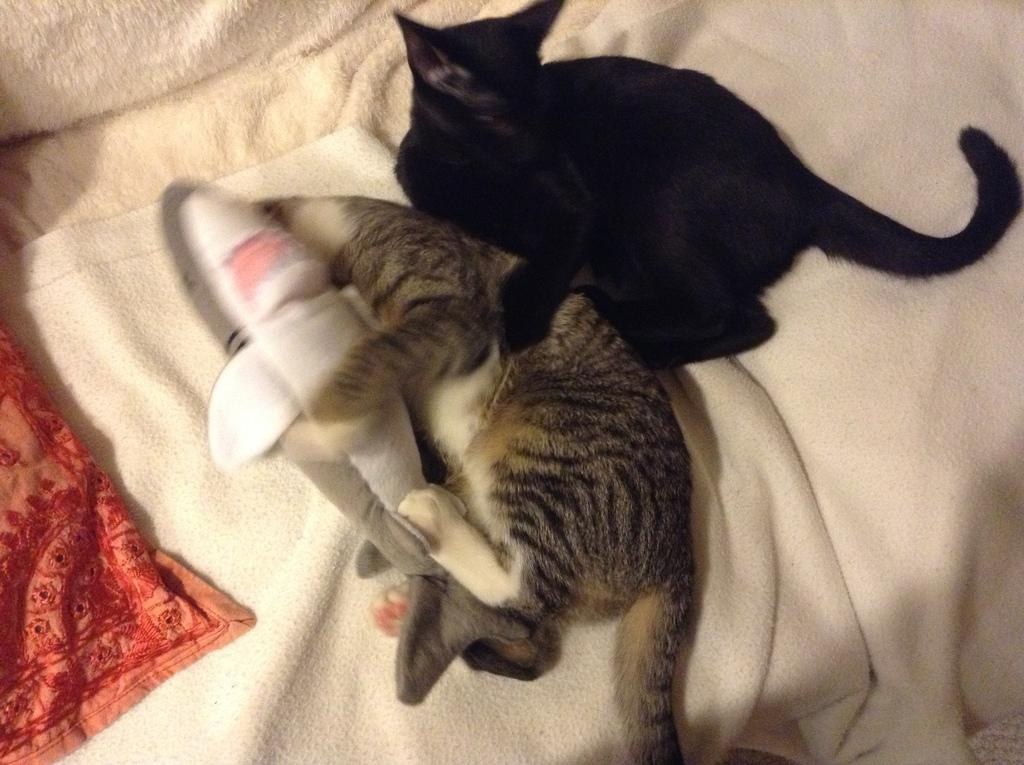What type of animals are in the image? There is a black cat and a grey cat in the image. What are the cats doing in the image? The cats are playing on a bed. What is covering the bed? There is a blanket on the bed. What toy can be seen on the left side of the bed? There is a dolphin toy on the left side of the bed. What historical event is depicted in the image? There is no historical event depicted in the image; it features two cats playing on a bed. What type of paper can be seen in the image? There is no paper present in the image. 